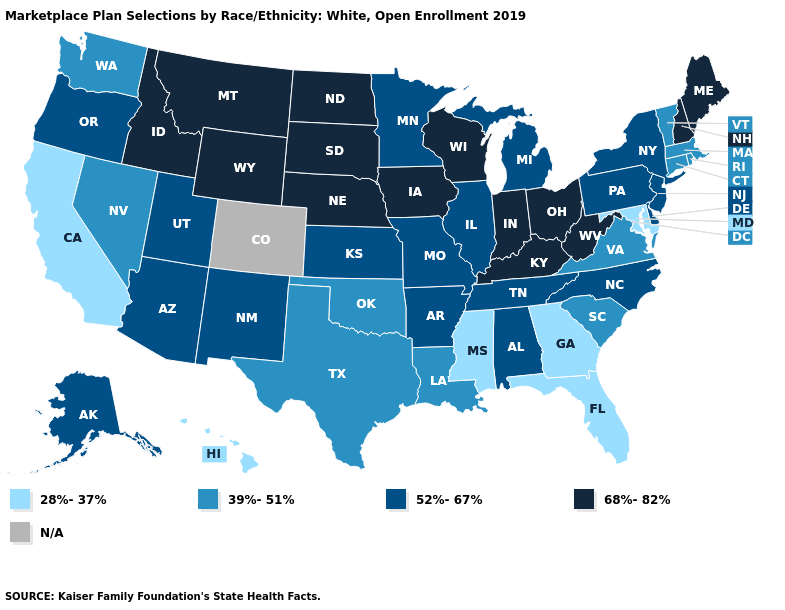What is the value of Washington?
Concise answer only. 39%-51%. Among the states that border Illinois , does Indiana have the lowest value?
Concise answer only. No. Name the states that have a value in the range 68%-82%?
Short answer required. Idaho, Indiana, Iowa, Kentucky, Maine, Montana, Nebraska, New Hampshire, North Dakota, Ohio, South Dakota, West Virginia, Wisconsin, Wyoming. What is the value of Wisconsin?
Quick response, please. 68%-82%. What is the value of Massachusetts?
Answer briefly. 39%-51%. Does the map have missing data?
Give a very brief answer. Yes. Does Tennessee have the lowest value in the USA?
Keep it brief. No. Name the states that have a value in the range 28%-37%?
Concise answer only. California, Florida, Georgia, Hawaii, Maryland, Mississippi. What is the value of Arkansas?
Write a very short answer. 52%-67%. How many symbols are there in the legend?
Keep it brief. 5. Name the states that have a value in the range N/A?
Short answer required. Colorado. What is the value of Utah?
Be succinct. 52%-67%. Which states have the highest value in the USA?
Short answer required. Idaho, Indiana, Iowa, Kentucky, Maine, Montana, Nebraska, New Hampshire, North Dakota, Ohio, South Dakota, West Virginia, Wisconsin, Wyoming. Name the states that have a value in the range 68%-82%?
Give a very brief answer. Idaho, Indiana, Iowa, Kentucky, Maine, Montana, Nebraska, New Hampshire, North Dakota, Ohio, South Dakota, West Virginia, Wisconsin, Wyoming. Name the states that have a value in the range 52%-67%?
Keep it brief. Alabama, Alaska, Arizona, Arkansas, Delaware, Illinois, Kansas, Michigan, Minnesota, Missouri, New Jersey, New Mexico, New York, North Carolina, Oregon, Pennsylvania, Tennessee, Utah. 